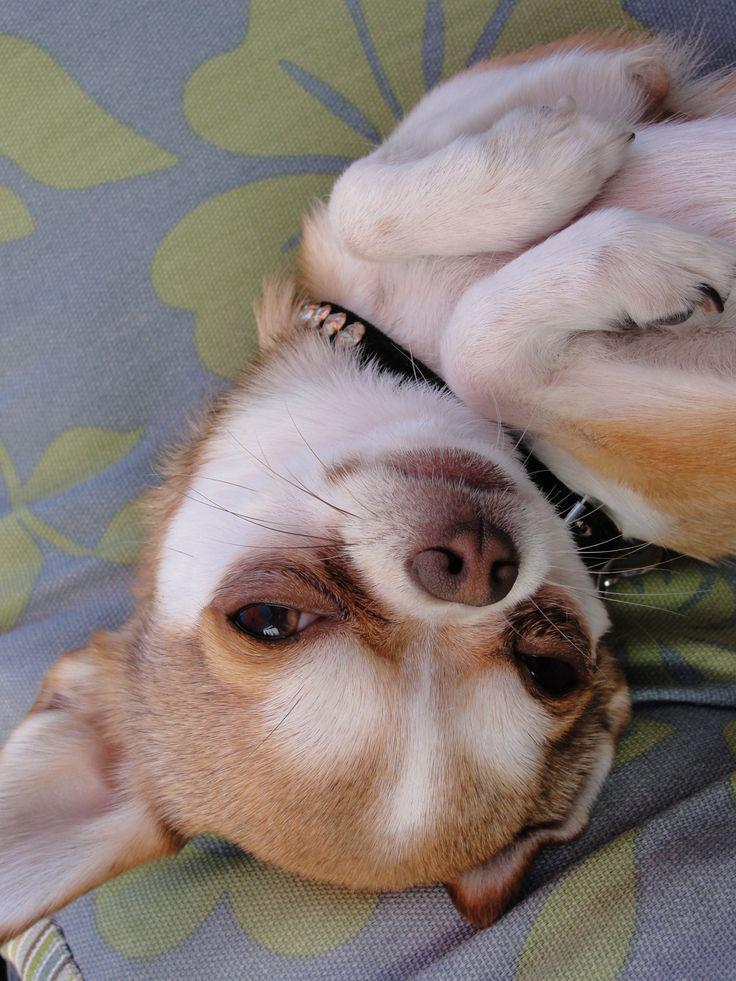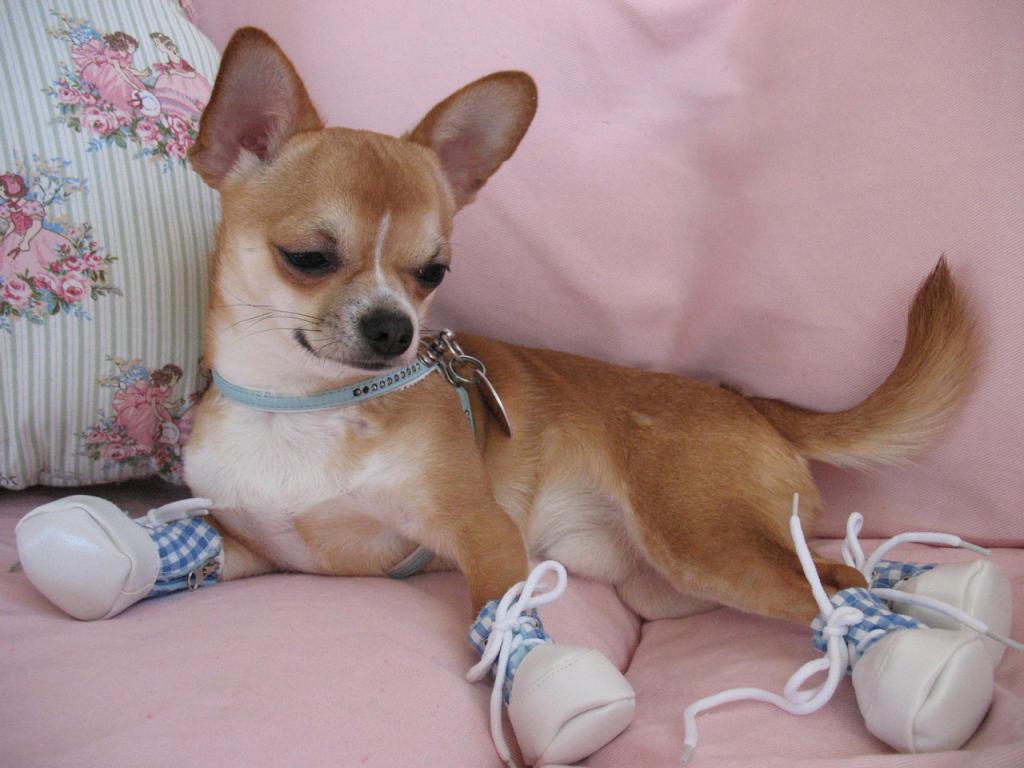The first image is the image on the left, the second image is the image on the right. Analyze the images presented: Is the assertion "One dog is wearing the kind of item people wear." valid? Answer yes or no. Yes. The first image is the image on the left, the second image is the image on the right. Analyze the images presented: Is the assertion "The dog in the image on the left is wearing a collar." valid? Answer yes or no. Yes. 